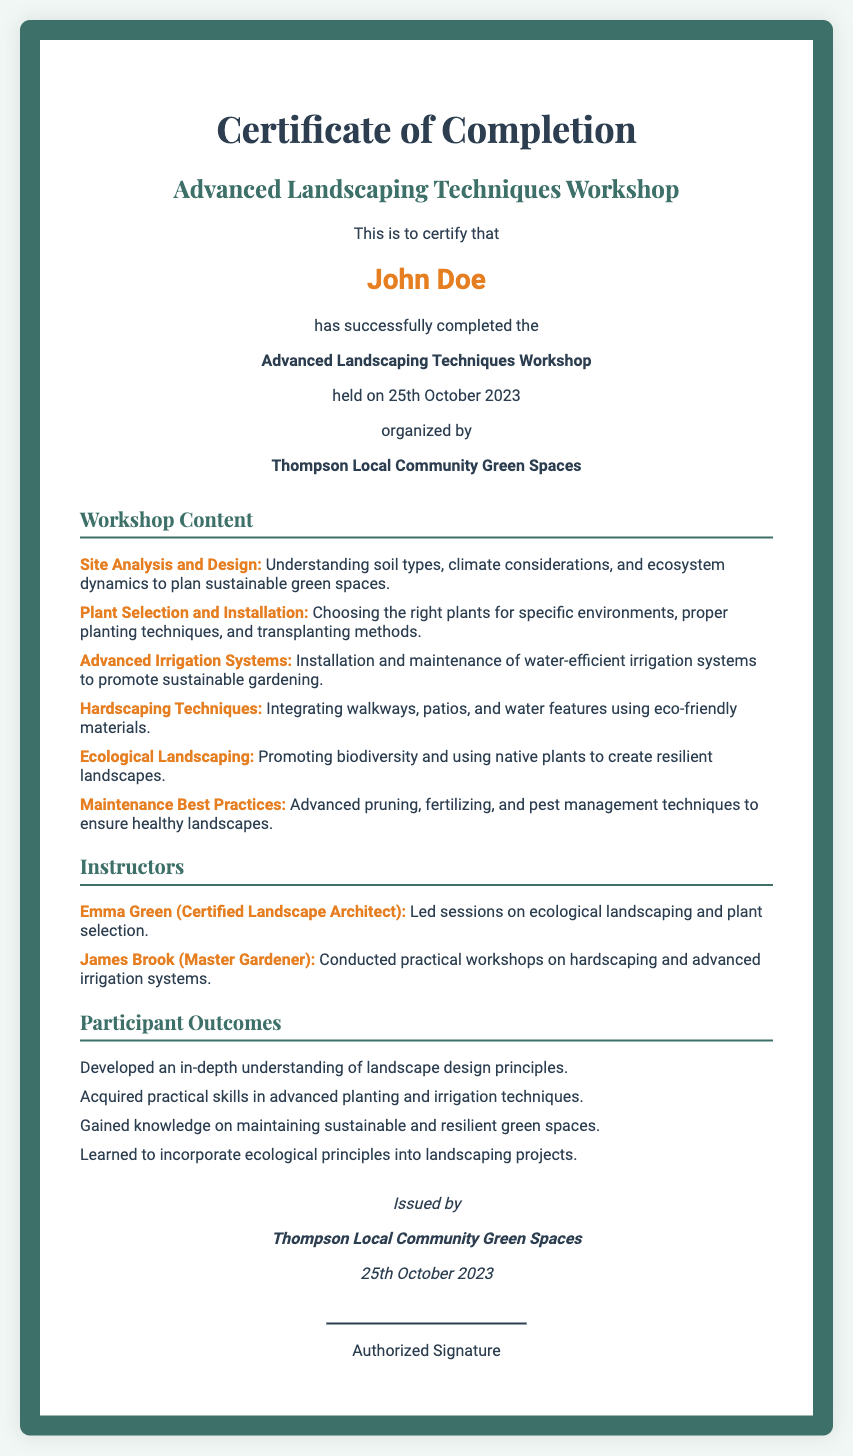What is the title of the workshop? The title is clearly stated in the document as "Advanced Landscaping Techniques Workshop."
Answer: Advanced Landscaping Techniques Workshop Who is the recipient of the certificate? The recipient is specified in the document and is named "John Doe."
Answer: John Doe What date was the workshop held? The date of the workshop is mentioned in the document as "25th October 2023."
Answer: 25th October 2023 Who organized the workshop? The organizing entity is presented in the document, which is "Thompson Local Community Green Spaces."
Answer: Thompson Local Community Green Spaces What is one topic covered in the workshop? Several topics are listed in the document, including "Site Analysis and Design."
Answer: Site Analysis and Design How many instructors are mentioned? The document lists two instructors, indicating their contribution to the workshop.
Answer: Two What is one participant outcome listed? One of the outcomes for participants is included in the document as understanding landscape design principles.
Answer: Developed an in-depth understanding of landscape design principles What is the name of the certified landscape architect? The document mentions "Emma Green" as the certified landscape architect who led specific sessions.
Answer: Emma Green What is the format of the document? The document is classified as a certificate of completion, which is indicated in its title.
Answer: Certificate of Completion 